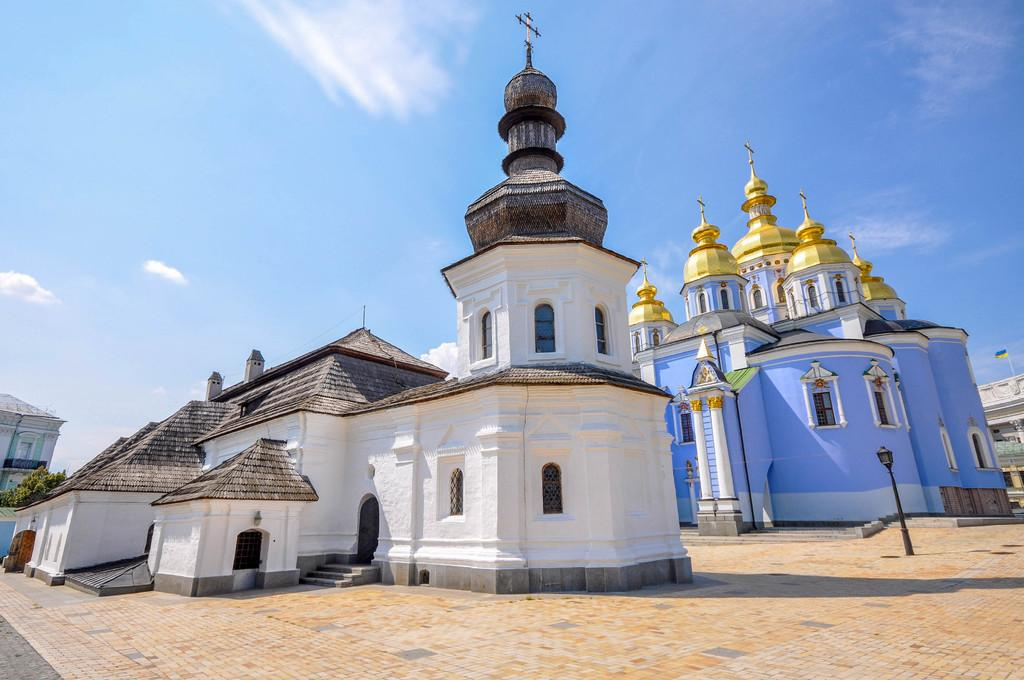What type of structures are depicted in the image? There are buildings in the image that resemble temples. What is located at the bottom of the image? There is a road at the bottom of the image. What can be seen in the sky at the top of the image? Clouds are visible in the sky at the top of the image. Where are the ants carrying the bone in the image? There are no ants or bones present in the image. What type of vase can be seen on the left side of the image? There is no vase present in the image. 